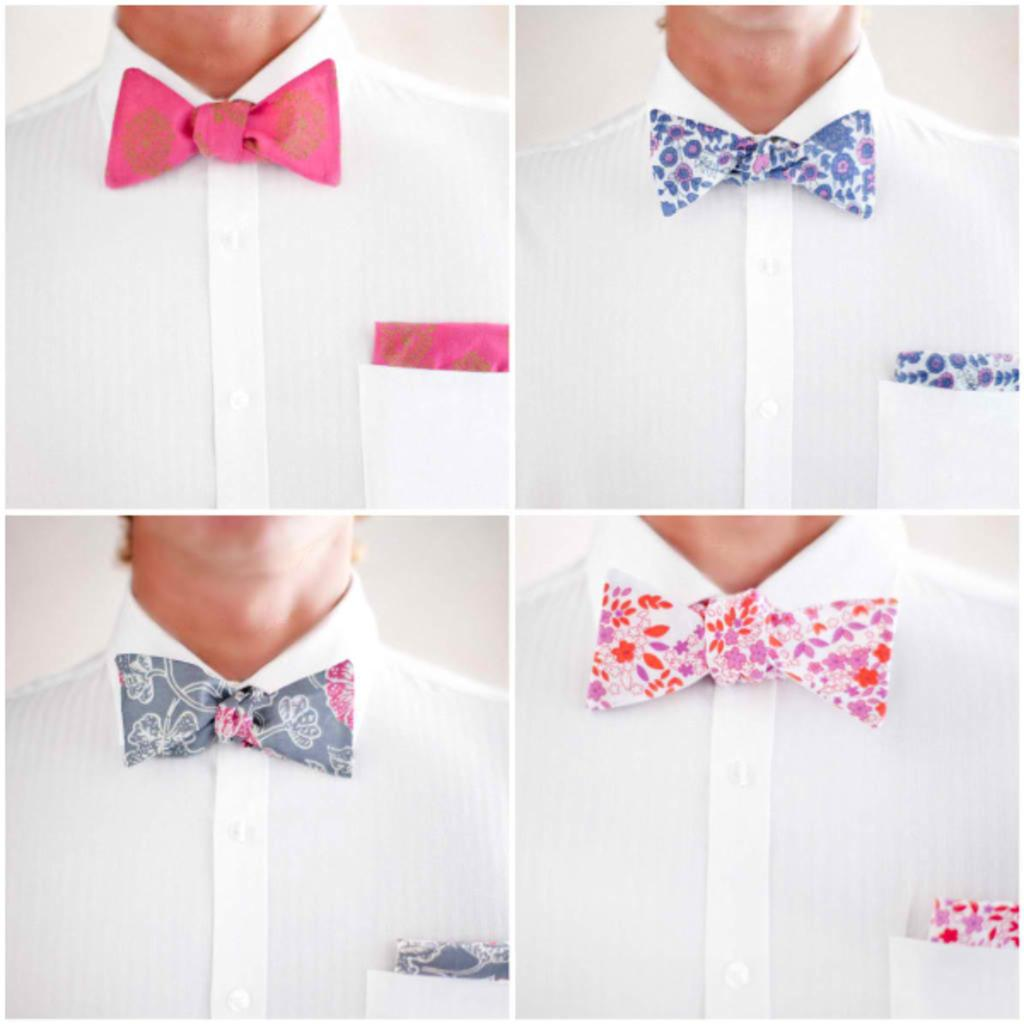What is the composition of the image? The image is a collage of four pictures. Can you describe any people in the collage? In the collage, there is a person. What type of accessories are featured in the collage? There are different colors of bow ties and kerchiefs in the collage. What type of slave is depicted in the collage? There is no depiction of a slave in the collage; it features a person wearing different colored bow ties and kerchiefs. What type of yam is being prepared in the collage? There is no depiction of food preparation or yams in the collage; it focuses on a person and their accessories. 